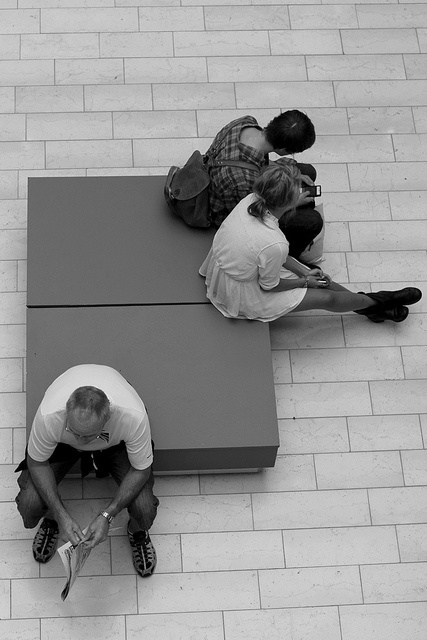Describe the objects in this image and their specific colors. I can see bench in lightgray, dimgray, black, and darkgray tones, people in lightgray, gray, black, and darkgray tones, people in lightgray, darkgray, black, and gray tones, people in lightgray, black, gray, and darkgray tones, and backpack in lightgray, black, gray, and darkgray tones in this image. 